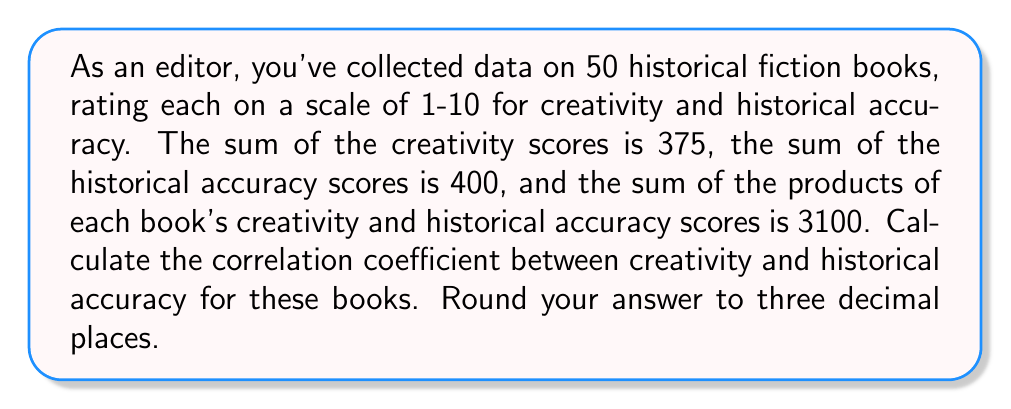Give your solution to this math problem. To calculate the correlation coefficient, we'll use the formula:

$$ r = \frac{n\sum xy - \sum x \sum y}{\sqrt{[n\sum x^2 - (\sum x)^2][n\sum y^2 - (\sum y)^2]}} $$

Where:
$n$ = number of books = 50
$x$ = creativity scores
$y$ = historical accuracy scores

We're given:
$\sum x = 375$
$\sum y = 400$
$\sum xy = 3100$

We need to calculate $\sum x^2$ and $\sum y^2$:

$\sum x^2 = \frac{(\sum x)^2 + n\sum xy - \sum x \sum y}{n} = \frac{375^2 + 50(3100) - 375(400)}{50} = 2962.5$

$\sum y^2 = \frac{(\sum y)^2 + n\sum xy - \sum x \sum y}{n} = \frac{400^2 + 50(3100) - 375(400)}{50} = 3300$

Now we can substitute these values into the correlation coefficient formula:

$$ r = \frac{50(3100) - 375(400)}{\sqrt{[50(2962.5) - 375^2][50(3300) - 400^2]}} $$

$$ = \frac{155000 - 150000}{\sqrt{[148125 - 140625][165000 - 160000]}} $$

$$ = \frac{5000}{\sqrt{7500 \cdot 5000}} $$

$$ = \frac{5000}{\sqrt{37500000}} $$

$$ = \frac{5000}{6123.724} $$

$$ \approx 0.816 $$
Answer: 0.816 